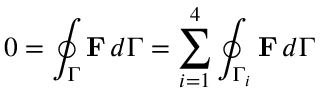Convert formula to latex. <formula><loc_0><loc_0><loc_500><loc_500>0 = \oint _ { \Gamma } F \, d \Gamma = \sum _ { i = 1 } ^ { 4 } \oint _ { \Gamma _ { i } } F \, d \Gamma</formula> 